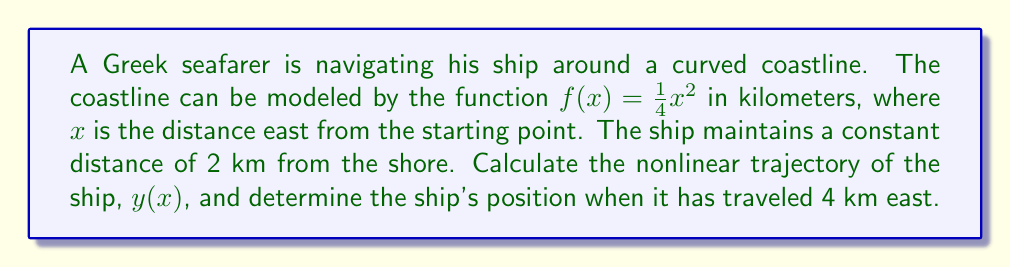Solve this math problem. 1) The coastline is given by $f(x) = \frac{1}{4}x^2$.

2) At any point $(x, y)$ on the ship's trajectory, the distance to the nearest point on the coastline $(x, f(x))$ is 2 km. We can express this using the distance formula:

   $$(y - f(x))^2 + (0)^2 = 2^2$$

3) Simplify:
   $$(y - \frac{1}{4}x^2)^2 = 4$$

4) Take the square root of both sides. Since $y > f(x)$ (the ship is north of the coastline), we use the positive root:
   $$y - \frac{1}{4}x^2 = 2$$

5) Solve for $y$ to get the ship's trajectory:
   $$y(x) = \frac{1}{4}x^2 + 2$$

6) To find the ship's position when it has traveled 4 km east, substitute $x = 4$ into $y(x)$:
   $$y(4) = \frac{1}{4}(4)^2 + 2 = 4 + 2 = 6$$

7) Therefore, when the ship has traveled 4 km east, its position will be (4, 6) in our coordinate system.

[asy]
import graph;
size(200);
real f(real x) {return 0.25*x^2;}
real g(real x) {return 0.25*x^2 + 2;}
draw(graph(f,0,4.5),blue);
draw(graph(g,0,4.5),red);
dot((4,6),red);
label("Coastline",(-0.5,4),W,blue);
label("Ship's trajectory",(-0.5,6),W,red);
label("(4, 6)",(4,6),NE,red);
xaxis("x (km)",arrow=Arrow);
yaxis("y (km)",arrow=Arrow);
[/asy]
Answer: $y(x) = \frac{1}{4}x^2 + 2$; (4, 6) 